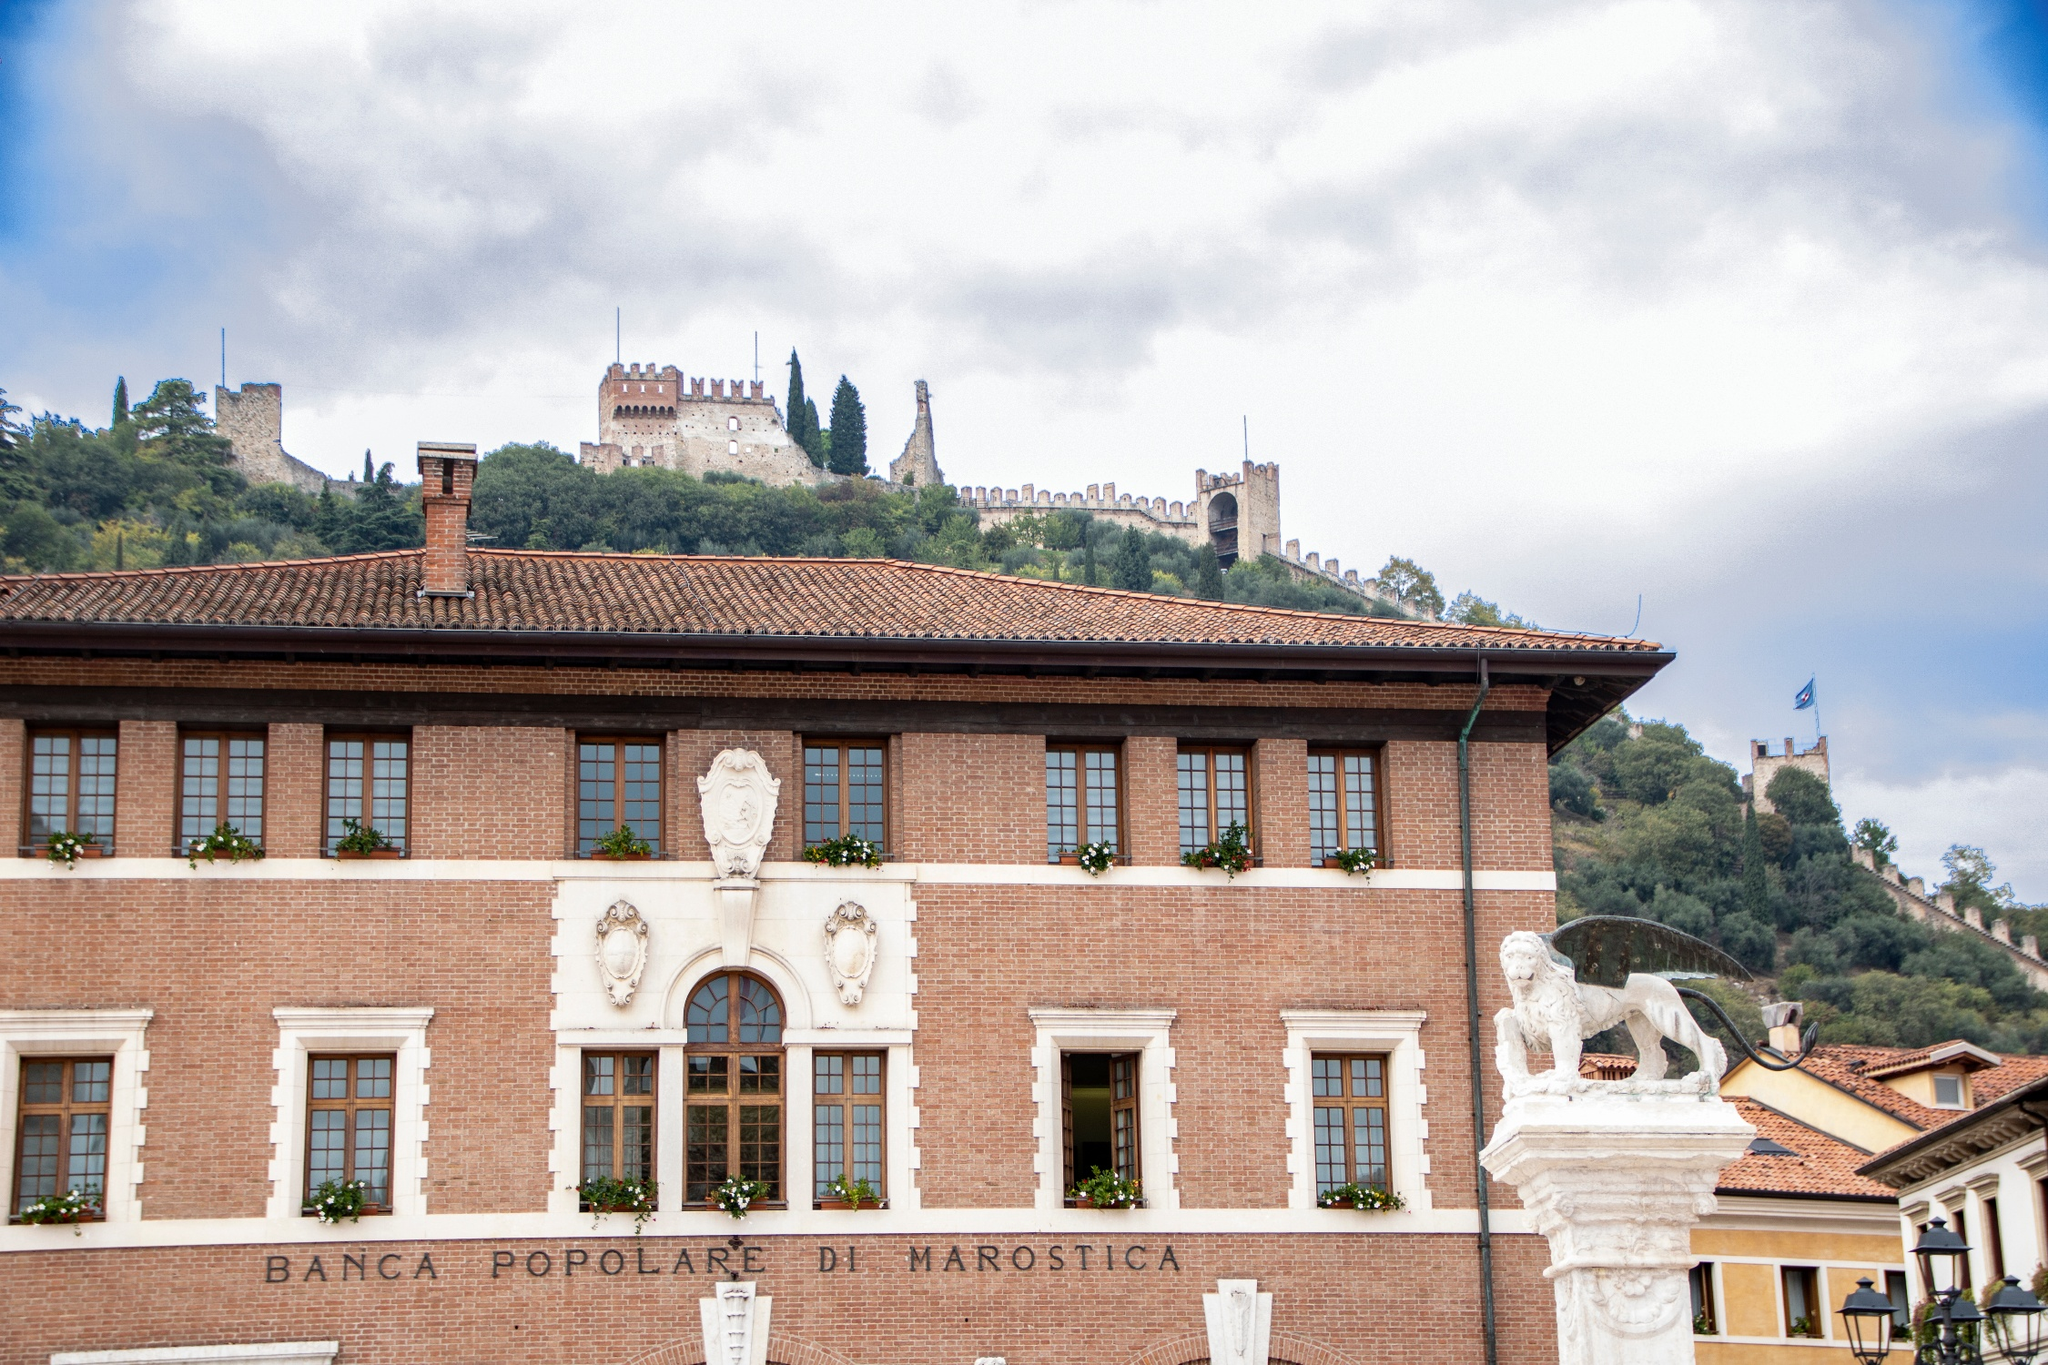Describe the historical significance of the buildings shown in the image. The buildings in the image are rich with historical significance, particularly Banca Popolare di Marostica and the Castello di Marostica. The Banca Popolare di Marostica, a beautiful two-story structure, reflects the town's architectural sensibilities, combining traditional brick construction with elegant white trim and charming window flower boxes. This bank represents both the economic and cultural history of Marostica, standing as a symbol of the town's prosperity over time.

Above the bank, perched on the hill, is the impressive Castello di Marostica. This castle, with its stone walls and turrets, has withstood the test of time, representing the fortified history of the region. It is a reminder of the Medieval era when Marostica played a crucial role in local defense and governance. The castle's presence signifies a lineage of historical events, royal influences, and architectural advancements that have shaped Marostica into the town it is today. 